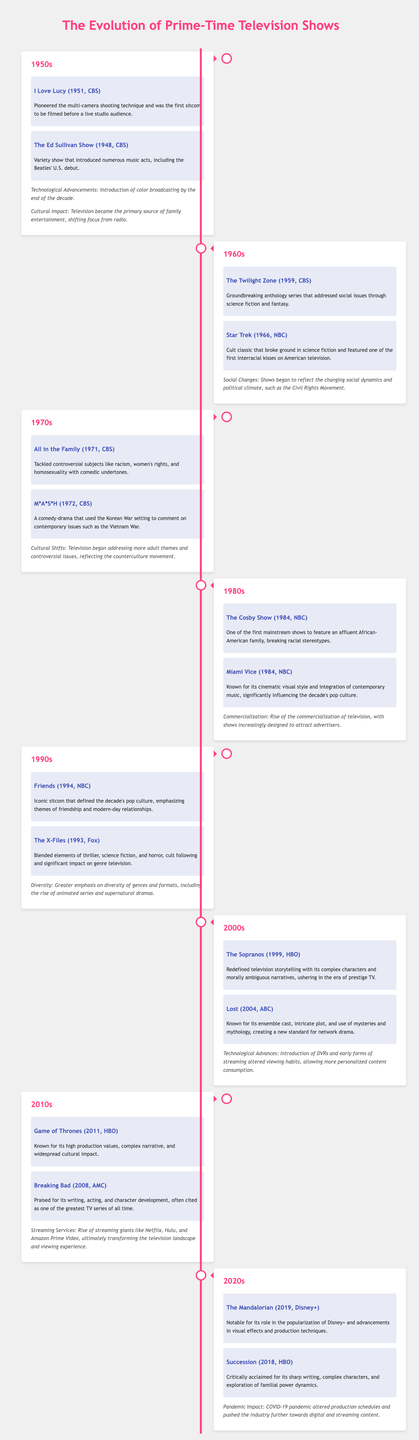What year did "I Love Lucy" premiere? "I Love Lucy" premiered in 1951, according to the timeline.
Answer: 1951 What show is known for its high production values in the 2010s? "Game of Thrones," noted for high production values and cultural impact, is highlighted in the 2010s section.
Answer: Game of Thrones Which show addressed social issues through science fiction in the 1960s? "The Twilight Zone" is mentioned as addressing social issues through science fiction and fantasy in the 1960s.
Answer: The Twilight Zone How did television programming address societal themes in the 1970s? The context states that television began addressing more adult themes and controversial issues, indicating a shift in programming in the 1970s.
Answer: Adult themes What significant technological advancement occurred in the 1950s? The document mentions the introduction of color broadcasting by the end of the 1950s.
Answer: Color broadcasting Which sitcom defined the 1990s pop culture? "Friends" is specified as the iconic sitcom that defined the decade’s pop culture in the 1990s.
Answer: Friends What impact did the COVID-19 pandemic have on television production? The context in the 2020s highlights that the pandemic altered production schedules and shifted towards digital content.
Answer: Altered production schedules Which show is recognized for breaking racial stereotypes in the 1980s? "The Cosby Show" is noted for featuring an affluent African-American family and breaking racial stereotypes during the 1980s.
Answer: The Cosby Show What was a notable feature of "Lost," mentioned in the 2000s? "Lost" is recognized for its ensemble cast and intricate plot, establishing new standards for network drama in the 2000s.
Answer: Ensemble cast 